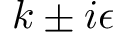<formula> <loc_0><loc_0><loc_500><loc_500>k \pm i \epsilon</formula> 